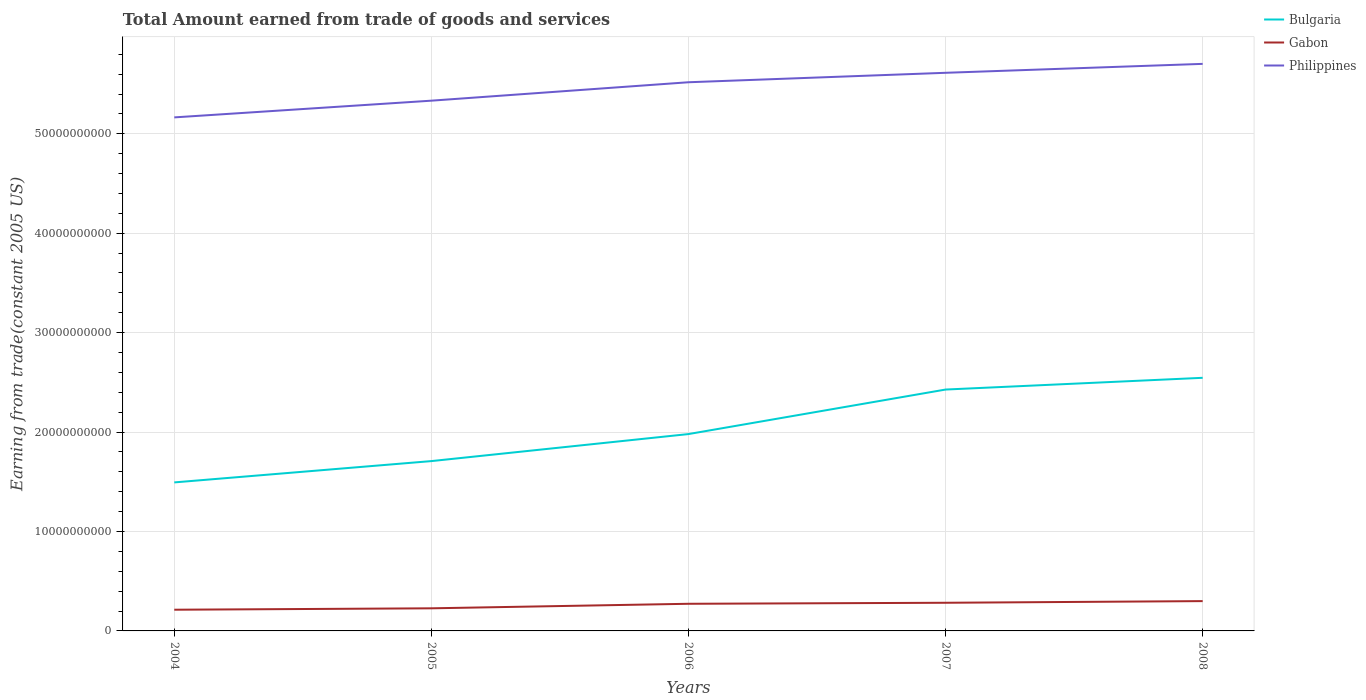Does the line corresponding to Philippines intersect with the line corresponding to Gabon?
Your response must be concise. No. Is the number of lines equal to the number of legend labels?
Keep it short and to the point. Yes. Across all years, what is the maximum total amount earned by trading goods and services in Philippines?
Your answer should be very brief. 5.16e+1. What is the total total amount earned by trading goods and services in Bulgaria in the graph?
Make the answer very short. -2.72e+09. What is the difference between the highest and the second highest total amount earned by trading goods and services in Bulgaria?
Your answer should be very brief. 1.05e+1. What is the difference between the highest and the lowest total amount earned by trading goods and services in Bulgaria?
Offer a very short reply. 2. How many lines are there?
Offer a terse response. 3. How many years are there in the graph?
Provide a short and direct response. 5. What is the title of the graph?
Offer a very short reply. Total Amount earned from trade of goods and services. What is the label or title of the X-axis?
Keep it short and to the point. Years. What is the label or title of the Y-axis?
Offer a terse response. Earning from trade(constant 2005 US). What is the Earning from trade(constant 2005 US) of Bulgaria in 2004?
Offer a terse response. 1.49e+1. What is the Earning from trade(constant 2005 US) of Gabon in 2004?
Your answer should be compact. 2.13e+09. What is the Earning from trade(constant 2005 US) of Philippines in 2004?
Ensure brevity in your answer.  5.16e+1. What is the Earning from trade(constant 2005 US) of Bulgaria in 2005?
Give a very brief answer. 1.71e+1. What is the Earning from trade(constant 2005 US) of Gabon in 2005?
Your answer should be very brief. 2.27e+09. What is the Earning from trade(constant 2005 US) in Philippines in 2005?
Ensure brevity in your answer.  5.33e+1. What is the Earning from trade(constant 2005 US) of Bulgaria in 2006?
Your answer should be very brief. 1.98e+1. What is the Earning from trade(constant 2005 US) of Gabon in 2006?
Ensure brevity in your answer.  2.73e+09. What is the Earning from trade(constant 2005 US) of Philippines in 2006?
Keep it short and to the point. 5.52e+1. What is the Earning from trade(constant 2005 US) in Bulgaria in 2007?
Your response must be concise. 2.43e+1. What is the Earning from trade(constant 2005 US) in Gabon in 2007?
Keep it short and to the point. 2.83e+09. What is the Earning from trade(constant 2005 US) of Philippines in 2007?
Provide a succinct answer. 5.61e+1. What is the Earning from trade(constant 2005 US) of Bulgaria in 2008?
Your answer should be very brief. 2.55e+1. What is the Earning from trade(constant 2005 US) in Gabon in 2008?
Provide a short and direct response. 3.00e+09. What is the Earning from trade(constant 2005 US) of Philippines in 2008?
Provide a succinct answer. 5.70e+1. Across all years, what is the maximum Earning from trade(constant 2005 US) of Bulgaria?
Give a very brief answer. 2.55e+1. Across all years, what is the maximum Earning from trade(constant 2005 US) in Gabon?
Provide a succinct answer. 3.00e+09. Across all years, what is the maximum Earning from trade(constant 2005 US) of Philippines?
Provide a short and direct response. 5.70e+1. Across all years, what is the minimum Earning from trade(constant 2005 US) of Bulgaria?
Give a very brief answer. 1.49e+1. Across all years, what is the minimum Earning from trade(constant 2005 US) of Gabon?
Offer a terse response. 2.13e+09. Across all years, what is the minimum Earning from trade(constant 2005 US) of Philippines?
Make the answer very short. 5.16e+1. What is the total Earning from trade(constant 2005 US) of Bulgaria in the graph?
Give a very brief answer. 1.02e+11. What is the total Earning from trade(constant 2005 US) of Gabon in the graph?
Your answer should be very brief. 1.30e+1. What is the total Earning from trade(constant 2005 US) in Philippines in the graph?
Your response must be concise. 2.73e+11. What is the difference between the Earning from trade(constant 2005 US) in Bulgaria in 2004 and that in 2005?
Your answer should be very brief. -2.14e+09. What is the difference between the Earning from trade(constant 2005 US) of Gabon in 2004 and that in 2005?
Your response must be concise. -1.42e+08. What is the difference between the Earning from trade(constant 2005 US) of Philippines in 2004 and that in 2005?
Give a very brief answer. -1.68e+09. What is the difference between the Earning from trade(constant 2005 US) in Bulgaria in 2004 and that in 2006?
Your answer should be compact. -4.86e+09. What is the difference between the Earning from trade(constant 2005 US) in Gabon in 2004 and that in 2006?
Give a very brief answer. -5.97e+08. What is the difference between the Earning from trade(constant 2005 US) in Philippines in 2004 and that in 2006?
Offer a terse response. -3.53e+09. What is the difference between the Earning from trade(constant 2005 US) of Bulgaria in 2004 and that in 2007?
Give a very brief answer. -9.34e+09. What is the difference between the Earning from trade(constant 2005 US) of Gabon in 2004 and that in 2007?
Provide a succinct answer. -6.99e+08. What is the difference between the Earning from trade(constant 2005 US) of Philippines in 2004 and that in 2007?
Keep it short and to the point. -4.49e+09. What is the difference between the Earning from trade(constant 2005 US) of Bulgaria in 2004 and that in 2008?
Give a very brief answer. -1.05e+1. What is the difference between the Earning from trade(constant 2005 US) in Gabon in 2004 and that in 2008?
Provide a succinct answer. -8.67e+08. What is the difference between the Earning from trade(constant 2005 US) of Philippines in 2004 and that in 2008?
Make the answer very short. -5.38e+09. What is the difference between the Earning from trade(constant 2005 US) in Bulgaria in 2005 and that in 2006?
Make the answer very short. -2.72e+09. What is the difference between the Earning from trade(constant 2005 US) of Gabon in 2005 and that in 2006?
Offer a very short reply. -4.55e+08. What is the difference between the Earning from trade(constant 2005 US) of Philippines in 2005 and that in 2006?
Provide a succinct answer. -1.85e+09. What is the difference between the Earning from trade(constant 2005 US) in Bulgaria in 2005 and that in 2007?
Keep it short and to the point. -7.20e+09. What is the difference between the Earning from trade(constant 2005 US) of Gabon in 2005 and that in 2007?
Ensure brevity in your answer.  -5.56e+08. What is the difference between the Earning from trade(constant 2005 US) of Philippines in 2005 and that in 2007?
Provide a succinct answer. -2.80e+09. What is the difference between the Earning from trade(constant 2005 US) in Bulgaria in 2005 and that in 2008?
Your answer should be very brief. -8.38e+09. What is the difference between the Earning from trade(constant 2005 US) of Gabon in 2005 and that in 2008?
Your response must be concise. -7.24e+08. What is the difference between the Earning from trade(constant 2005 US) of Philippines in 2005 and that in 2008?
Make the answer very short. -3.70e+09. What is the difference between the Earning from trade(constant 2005 US) in Bulgaria in 2006 and that in 2007?
Ensure brevity in your answer.  -4.48e+09. What is the difference between the Earning from trade(constant 2005 US) of Gabon in 2006 and that in 2007?
Keep it short and to the point. -1.02e+08. What is the difference between the Earning from trade(constant 2005 US) in Philippines in 2006 and that in 2007?
Give a very brief answer. -9.50e+08. What is the difference between the Earning from trade(constant 2005 US) in Bulgaria in 2006 and that in 2008?
Provide a succinct answer. -5.66e+09. What is the difference between the Earning from trade(constant 2005 US) in Gabon in 2006 and that in 2008?
Your answer should be very brief. -2.69e+08. What is the difference between the Earning from trade(constant 2005 US) in Philippines in 2006 and that in 2008?
Offer a terse response. -1.85e+09. What is the difference between the Earning from trade(constant 2005 US) of Bulgaria in 2007 and that in 2008?
Give a very brief answer. -1.18e+09. What is the difference between the Earning from trade(constant 2005 US) in Gabon in 2007 and that in 2008?
Offer a very short reply. -1.68e+08. What is the difference between the Earning from trade(constant 2005 US) in Philippines in 2007 and that in 2008?
Ensure brevity in your answer.  -8.98e+08. What is the difference between the Earning from trade(constant 2005 US) in Bulgaria in 2004 and the Earning from trade(constant 2005 US) in Gabon in 2005?
Ensure brevity in your answer.  1.27e+1. What is the difference between the Earning from trade(constant 2005 US) of Bulgaria in 2004 and the Earning from trade(constant 2005 US) of Philippines in 2005?
Your response must be concise. -3.84e+1. What is the difference between the Earning from trade(constant 2005 US) in Gabon in 2004 and the Earning from trade(constant 2005 US) in Philippines in 2005?
Keep it short and to the point. -5.12e+1. What is the difference between the Earning from trade(constant 2005 US) of Bulgaria in 2004 and the Earning from trade(constant 2005 US) of Gabon in 2006?
Your answer should be very brief. 1.22e+1. What is the difference between the Earning from trade(constant 2005 US) of Bulgaria in 2004 and the Earning from trade(constant 2005 US) of Philippines in 2006?
Provide a succinct answer. -4.02e+1. What is the difference between the Earning from trade(constant 2005 US) in Gabon in 2004 and the Earning from trade(constant 2005 US) in Philippines in 2006?
Your answer should be compact. -5.31e+1. What is the difference between the Earning from trade(constant 2005 US) in Bulgaria in 2004 and the Earning from trade(constant 2005 US) in Gabon in 2007?
Make the answer very short. 1.21e+1. What is the difference between the Earning from trade(constant 2005 US) in Bulgaria in 2004 and the Earning from trade(constant 2005 US) in Philippines in 2007?
Your answer should be compact. -4.12e+1. What is the difference between the Earning from trade(constant 2005 US) in Gabon in 2004 and the Earning from trade(constant 2005 US) in Philippines in 2007?
Your answer should be very brief. -5.40e+1. What is the difference between the Earning from trade(constant 2005 US) in Bulgaria in 2004 and the Earning from trade(constant 2005 US) in Gabon in 2008?
Your answer should be compact. 1.19e+1. What is the difference between the Earning from trade(constant 2005 US) of Bulgaria in 2004 and the Earning from trade(constant 2005 US) of Philippines in 2008?
Ensure brevity in your answer.  -4.21e+1. What is the difference between the Earning from trade(constant 2005 US) in Gabon in 2004 and the Earning from trade(constant 2005 US) in Philippines in 2008?
Your answer should be very brief. -5.49e+1. What is the difference between the Earning from trade(constant 2005 US) of Bulgaria in 2005 and the Earning from trade(constant 2005 US) of Gabon in 2006?
Give a very brief answer. 1.44e+1. What is the difference between the Earning from trade(constant 2005 US) of Bulgaria in 2005 and the Earning from trade(constant 2005 US) of Philippines in 2006?
Keep it short and to the point. -3.81e+1. What is the difference between the Earning from trade(constant 2005 US) of Gabon in 2005 and the Earning from trade(constant 2005 US) of Philippines in 2006?
Keep it short and to the point. -5.29e+1. What is the difference between the Earning from trade(constant 2005 US) of Bulgaria in 2005 and the Earning from trade(constant 2005 US) of Gabon in 2007?
Offer a terse response. 1.42e+1. What is the difference between the Earning from trade(constant 2005 US) of Bulgaria in 2005 and the Earning from trade(constant 2005 US) of Philippines in 2007?
Keep it short and to the point. -3.91e+1. What is the difference between the Earning from trade(constant 2005 US) of Gabon in 2005 and the Earning from trade(constant 2005 US) of Philippines in 2007?
Give a very brief answer. -5.39e+1. What is the difference between the Earning from trade(constant 2005 US) in Bulgaria in 2005 and the Earning from trade(constant 2005 US) in Gabon in 2008?
Your response must be concise. 1.41e+1. What is the difference between the Earning from trade(constant 2005 US) of Bulgaria in 2005 and the Earning from trade(constant 2005 US) of Philippines in 2008?
Your answer should be very brief. -4.00e+1. What is the difference between the Earning from trade(constant 2005 US) of Gabon in 2005 and the Earning from trade(constant 2005 US) of Philippines in 2008?
Keep it short and to the point. -5.48e+1. What is the difference between the Earning from trade(constant 2005 US) in Bulgaria in 2006 and the Earning from trade(constant 2005 US) in Gabon in 2007?
Ensure brevity in your answer.  1.70e+1. What is the difference between the Earning from trade(constant 2005 US) of Bulgaria in 2006 and the Earning from trade(constant 2005 US) of Philippines in 2007?
Make the answer very short. -3.63e+1. What is the difference between the Earning from trade(constant 2005 US) of Gabon in 2006 and the Earning from trade(constant 2005 US) of Philippines in 2007?
Keep it short and to the point. -5.34e+1. What is the difference between the Earning from trade(constant 2005 US) in Bulgaria in 2006 and the Earning from trade(constant 2005 US) in Gabon in 2008?
Provide a short and direct response. 1.68e+1. What is the difference between the Earning from trade(constant 2005 US) in Bulgaria in 2006 and the Earning from trade(constant 2005 US) in Philippines in 2008?
Provide a succinct answer. -3.72e+1. What is the difference between the Earning from trade(constant 2005 US) of Gabon in 2006 and the Earning from trade(constant 2005 US) of Philippines in 2008?
Your answer should be very brief. -5.43e+1. What is the difference between the Earning from trade(constant 2005 US) in Bulgaria in 2007 and the Earning from trade(constant 2005 US) in Gabon in 2008?
Keep it short and to the point. 2.13e+1. What is the difference between the Earning from trade(constant 2005 US) in Bulgaria in 2007 and the Earning from trade(constant 2005 US) in Philippines in 2008?
Your answer should be compact. -3.28e+1. What is the difference between the Earning from trade(constant 2005 US) of Gabon in 2007 and the Earning from trade(constant 2005 US) of Philippines in 2008?
Give a very brief answer. -5.42e+1. What is the average Earning from trade(constant 2005 US) in Bulgaria per year?
Give a very brief answer. 2.03e+1. What is the average Earning from trade(constant 2005 US) in Gabon per year?
Your answer should be very brief. 2.59e+09. What is the average Earning from trade(constant 2005 US) of Philippines per year?
Your response must be concise. 5.47e+1. In the year 2004, what is the difference between the Earning from trade(constant 2005 US) in Bulgaria and Earning from trade(constant 2005 US) in Gabon?
Offer a very short reply. 1.28e+1. In the year 2004, what is the difference between the Earning from trade(constant 2005 US) of Bulgaria and Earning from trade(constant 2005 US) of Philippines?
Give a very brief answer. -3.67e+1. In the year 2004, what is the difference between the Earning from trade(constant 2005 US) in Gabon and Earning from trade(constant 2005 US) in Philippines?
Provide a short and direct response. -4.95e+1. In the year 2005, what is the difference between the Earning from trade(constant 2005 US) of Bulgaria and Earning from trade(constant 2005 US) of Gabon?
Offer a very short reply. 1.48e+1. In the year 2005, what is the difference between the Earning from trade(constant 2005 US) of Bulgaria and Earning from trade(constant 2005 US) of Philippines?
Give a very brief answer. -3.63e+1. In the year 2005, what is the difference between the Earning from trade(constant 2005 US) in Gabon and Earning from trade(constant 2005 US) in Philippines?
Provide a short and direct response. -5.11e+1. In the year 2006, what is the difference between the Earning from trade(constant 2005 US) of Bulgaria and Earning from trade(constant 2005 US) of Gabon?
Make the answer very short. 1.71e+1. In the year 2006, what is the difference between the Earning from trade(constant 2005 US) of Bulgaria and Earning from trade(constant 2005 US) of Philippines?
Your answer should be compact. -3.54e+1. In the year 2006, what is the difference between the Earning from trade(constant 2005 US) in Gabon and Earning from trade(constant 2005 US) in Philippines?
Offer a terse response. -5.25e+1. In the year 2007, what is the difference between the Earning from trade(constant 2005 US) in Bulgaria and Earning from trade(constant 2005 US) in Gabon?
Offer a very short reply. 2.14e+1. In the year 2007, what is the difference between the Earning from trade(constant 2005 US) of Bulgaria and Earning from trade(constant 2005 US) of Philippines?
Your answer should be compact. -3.19e+1. In the year 2007, what is the difference between the Earning from trade(constant 2005 US) of Gabon and Earning from trade(constant 2005 US) of Philippines?
Provide a short and direct response. -5.33e+1. In the year 2008, what is the difference between the Earning from trade(constant 2005 US) of Bulgaria and Earning from trade(constant 2005 US) of Gabon?
Your answer should be compact. 2.25e+1. In the year 2008, what is the difference between the Earning from trade(constant 2005 US) of Bulgaria and Earning from trade(constant 2005 US) of Philippines?
Give a very brief answer. -3.16e+1. In the year 2008, what is the difference between the Earning from trade(constant 2005 US) of Gabon and Earning from trade(constant 2005 US) of Philippines?
Provide a succinct answer. -5.40e+1. What is the ratio of the Earning from trade(constant 2005 US) of Bulgaria in 2004 to that in 2005?
Keep it short and to the point. 0.87. What is the ratio of the Earning from trade(constant 2005 US) in Philippines in 2004 to that in 2005?
Provide a short and direct response. 0.97. What is the ratio of the Earning from trade(constant 2005 US) in Bulgaria in 2004 to that in 2006?
Your response must be concise. 0.75. What is the ratio of the Earning from trade(constant 2005 US) in Gabon in 2004 to that in 2006?
Keep it short and to the point. 0.78. What is the ratio of the Earning from trade(constant 2005 US) in Philippines in 2004 to that in 2006?
Your answer should be compact. 0.94. What is the ratio of the Earning from trade(constant 2005 US) in Bulgaria in 2004 to that in 2007?
Keep it short and to the point. 0.62. What is the ratio of the Earning from trade(constant 2005 US) of Gabon in 2004 to that in 2007?
Keep it short and to the point. 0.75. What is the ratio of the Earning from trade(constant 2005 US) of Philippines in 2004 to that in 2007?
Give a very brief answer. 0.92. What is the ratio of the Earning from trade(constant 2005 US) of Bulgaria in 2004 to that in 2008?
Offer a terse response. 0.59. What is the ratio of the Earning from trade(constant 2005 US) in Gabon in 2004 to that in 2008?
Keep it short and to the point. 0.71. What is the ratio of the Earning from trade(constant 2005 US) of Philippines in 2004 to that in 2008?
Give a very brief answer. 0.91. What is the ratio of the Earning from trade(constant 2005 US) of Bulgaria in 2005 to that in 2006?
Your response must be concise. 0.86. What is the ratio of the Earning from trade(constant 2005 US) of Gabon in 2005 to that in 2006?
Your response must be concise. 0.83. What is the ratio of the Earning from trade(constant 2005 US) in Philippines in 2005 to that in 2006?
Keep it short and to the point. 0.97. What is the ratio of the Earning from trade(constant 2005 US) in Bulgaria in 2005 to that in 2007?
Ensure brevity in your answer.  0.7. What is the ratio of the Earning from trade(constant 2005 US) in Gabon in 2005 to that in 2007?
Your answer should be very brief. 0.8. What is the ratio of the Earning from trade(constant 2005 US) of Philippines in 2005 to that in 2007?
Offer a very short reply. 0.95. What is the ratio of the Earning from trade(constant 2005 US) of Bulgaria in 2005 to that in 2008?
Make the answer very short. 0.67. What is the ratio of the Earning from trade(constant 2005 US) of Gabon in 2005 to that in 2008?
Your answer should be very brief. 0.76. What is the ratio of the Earning from trade(constant 2005 US) of Philippines in 2005 to that in 2008?
Offer a very short reply. 0.94. What is the ratio of the Earning from trade(constant 2005 US) of Bulgaria in 2006 to that in 2007?
Your response must be concise. 0.82. What is the ratio of the Earning from trade(constant 2005 US) in Gabon in 2006 to that in 2007?
Give a very brief answer. 0.96. What is the ratio of the Earning from trade(constant 2005 US) in Philippines in 2006 to that in 2007?
Ensure brevity in your answer.  0.98. What is the ratio of the Earning from trade(constant 2005 US) of Bulgaria in 2006 to that in 2008?
Ensure brevity in your answer.  0.78. What is the ratio of the Earning from trade(constant 2005 US) of Gabon in 2006 to that in 2008?
Provide a succinct answer. 0.91. What is the ratio of the Earning from trade(constant 2005 US) of Philippines in 2006 to that in 2008?
Keep it short and to the point. 0.97. What is the ratio of the Earning from trade(constant 2005 US) of Bulgaria in 2007 to that in 2008?
Your response must be concise. 0.95. What is the ratio of the Earning from trade(constant 2005 US) of Gabon in 2007 to that in 2008?
Provide a short and direct response. 0.94. What is the ratio of the Earning from trade(constant 2005 US) of Philippines in 2007 to that in 2008?
Your answer should be very brief. 0.98. What is the difference between the highest and the second highest Earning from trade(constant 2005 US) of Bulgaria?
Your answer should be very brief. 1.18e+09. What is the difference between the highest and the second highest Earning from trade(constant 2005 US) of Gabon?
Make the answer very short. 1.68e+08. What is the difference between the highest and the second highest Earning from trade(constant 2005 US) in Philippines?
Offer a very short reply. 8.98e+08. What is the difference between the highest and the lowest Earning from trade(constant 2005 US) of Bulgaria?
Ensure brevity in your answer.  1.05e+1. What is the difference between the highest and the lowest Earning from trade(constant 2005 US) of Gabon?
Keep it short and to the point. 8.67e+08. What is the difference between the highest and the lowest Earning from trade(constant 2005 US) in Philippines?
Your response must be concise. 5.38e+09. 